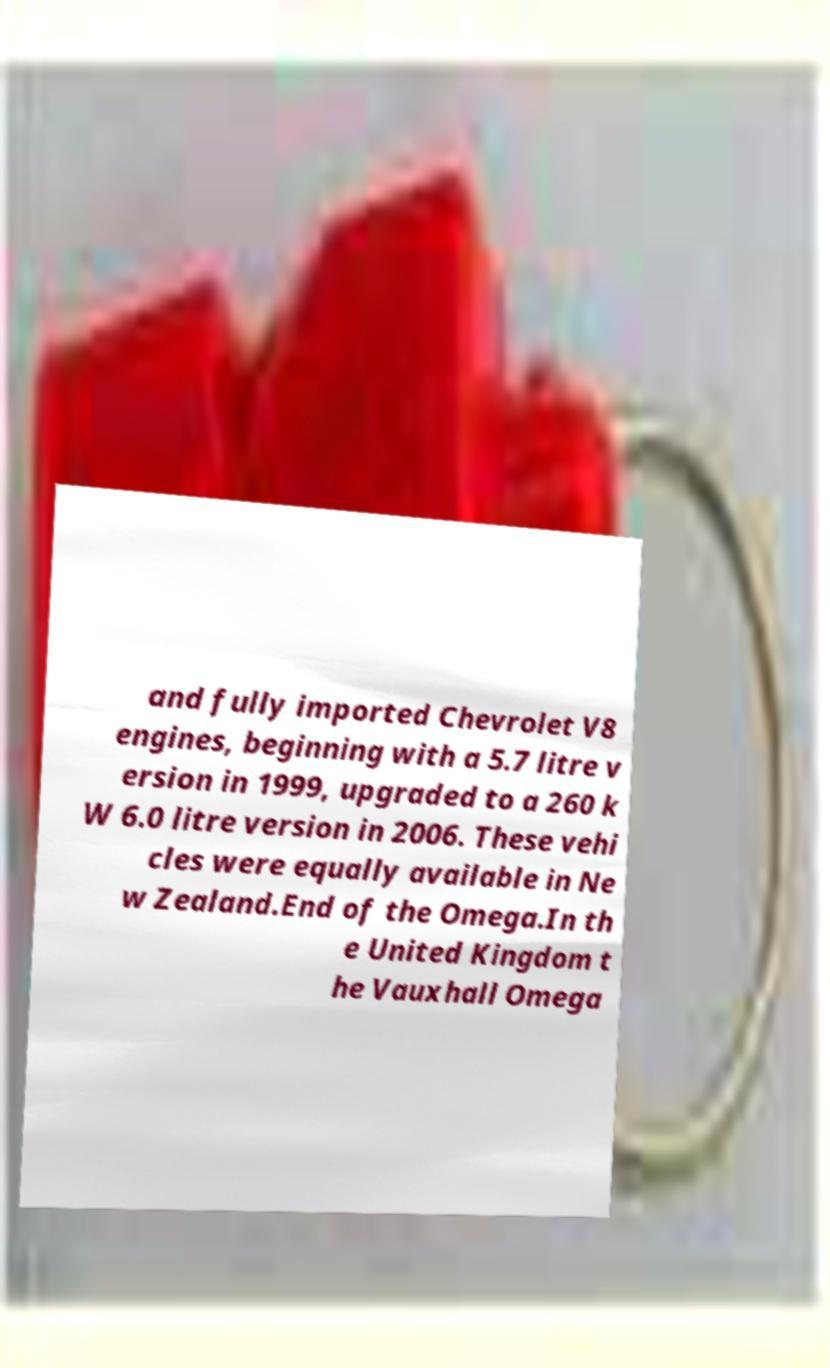Could you extract and type out the text from this image? and fully imported Chevrolet V8 engines, beginning with a 5.7 litre v ersion in 1999, upgraded to a 260 k W 6.0 litre version in 2006. These vehi cles were equally available in Ne w Zealand.End of the Omega.In th e United Kingdom t he Vauxhall Omega 